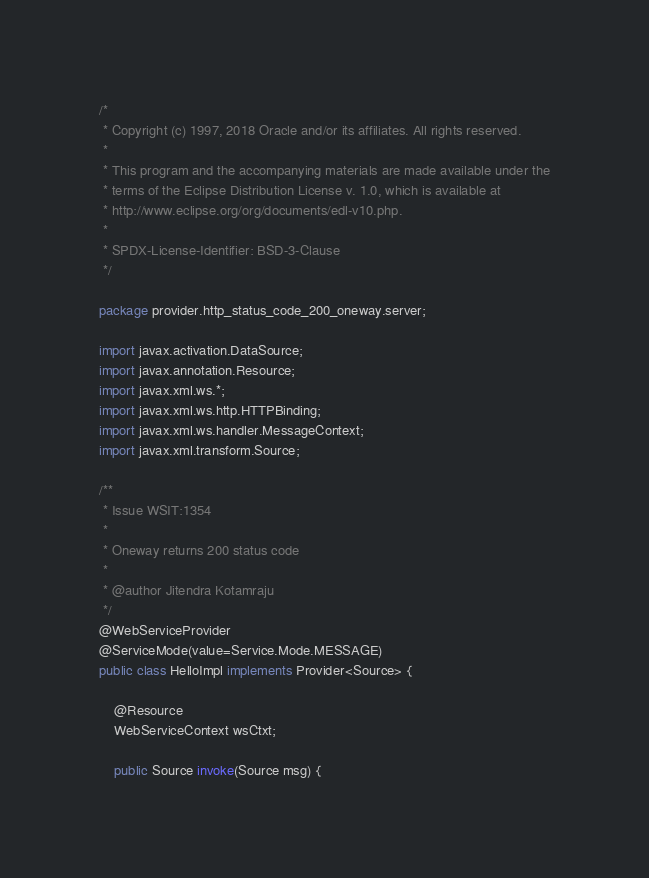Convert code to text. <code><loc_0><loc_0><loc_500><loc_500><_Java_>/*
 * Copyright (c) 1997, 2018 Oracle and/or its affiliates. All rights reserved.
 *
 * This program and the accompanying materials are made available under the
 * terms of the Eclipse Distribution License v. 1.0, which is available at
 * http://www.eclipse.org/org/documents/edl-v10.php.
 *
 * SPDX-License-Identifier: BSD-3-Clause
 */

package provider.http_status_code_200_oneway.server;

import javax.activation.DataSource;
import javax.annotation.Resource;
import javax.xml.ws.*;
import javax.xml.ws.http.HTTPBinding;
import javax.xml.ws.handler.MessageContext;
import javax.xml.transform.Source;

/**
 * Issue WSIT:1354
 *
 * Oneway returns 200 status code
 *
 * @author Jitendra Kotamraju
 */
@WebServiceProvider
@ServiceMode(value=Service.Mode.MESSAGE)
public class HelloImpl implements Provider<Source> {

    @Resource
    WebServiceContext wsCtxt;

    public Source invoke(Source msg) {</code> 